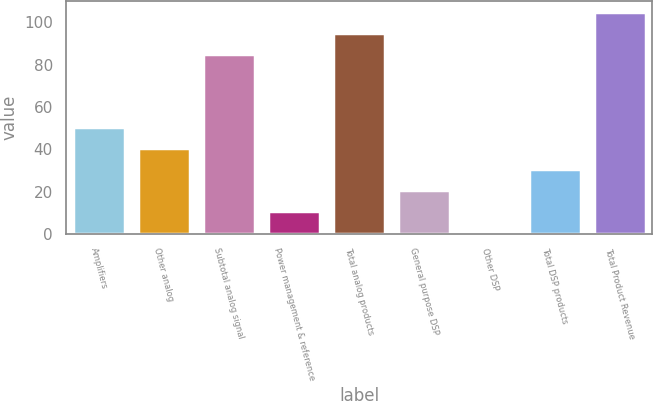<chart> <loc_0><loc_0><loc_500><loc_500><bar_chart><fcel>Amplifiers<fcel>Other analog<fcel>Subtotal analog signal<fcel>Power management & reference<fcel>Total analog products<fcel>General purpose DSP<fcel>Other DSP<fcel>Total DSP products<fcel>Total Product Revenue<nl><fcel>50.5<fcel>40.6<fcel>85<fcel>10.9<fcel>94.9<fcel>20.8<fcel>1<fcel>30.7<fcel>104.8<nl></chart> 